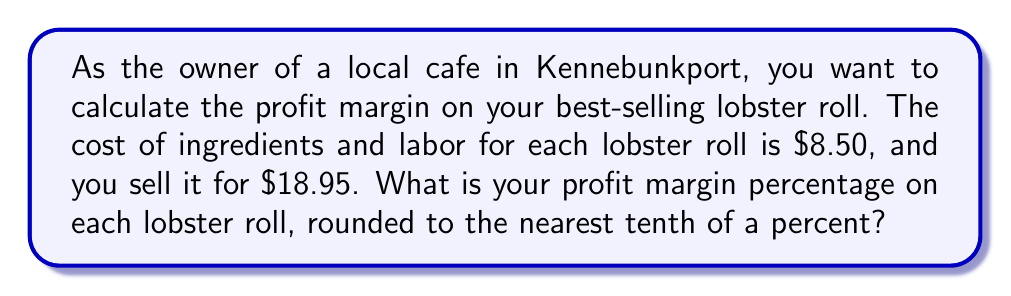Show me your answer to this math problem. To calculate the profit margin percentage, we need to follow these steps:

1. Calculate the profit per lobster roll:
   Profit = Selling price - Cost
   $$\text{Profit} = $18.95 - $8.50 = $10.45$$

2. Calculate the profit margin ratio:
   Profit margin ratio = Profit / Selling price
   $$\text{Profit margin ratio} = \frac{$10.45}{$18.95} \approx 0.5514$$

3. Convert the ratio to a percentage:
   Profit margin percentage = Profit margin ratio × 100%
   $$\text{Profit margin percentage} = 0.5514 \times 100\% \approx 55.14\%$$

4. Round to the nearest tenth of a percent:
   $$55.14\% \approx 55.1\%$$

Therefore, the profit margin percentage on each lobster roll is approximately 55.1%.
Answer: 55.1% 